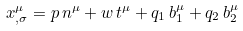<formula> <loc_0><loc_0><loc_500><loc_500>x ^ { \mu } _ { , \sigma } = p \, n ^ { \mu } + w \, t ^ { \mu } + q _ { 1 } \, b _ { 1 } ^ { \mu } + q _ { 2 } \, b _ { 2 } ^ { \mu }</formula> 